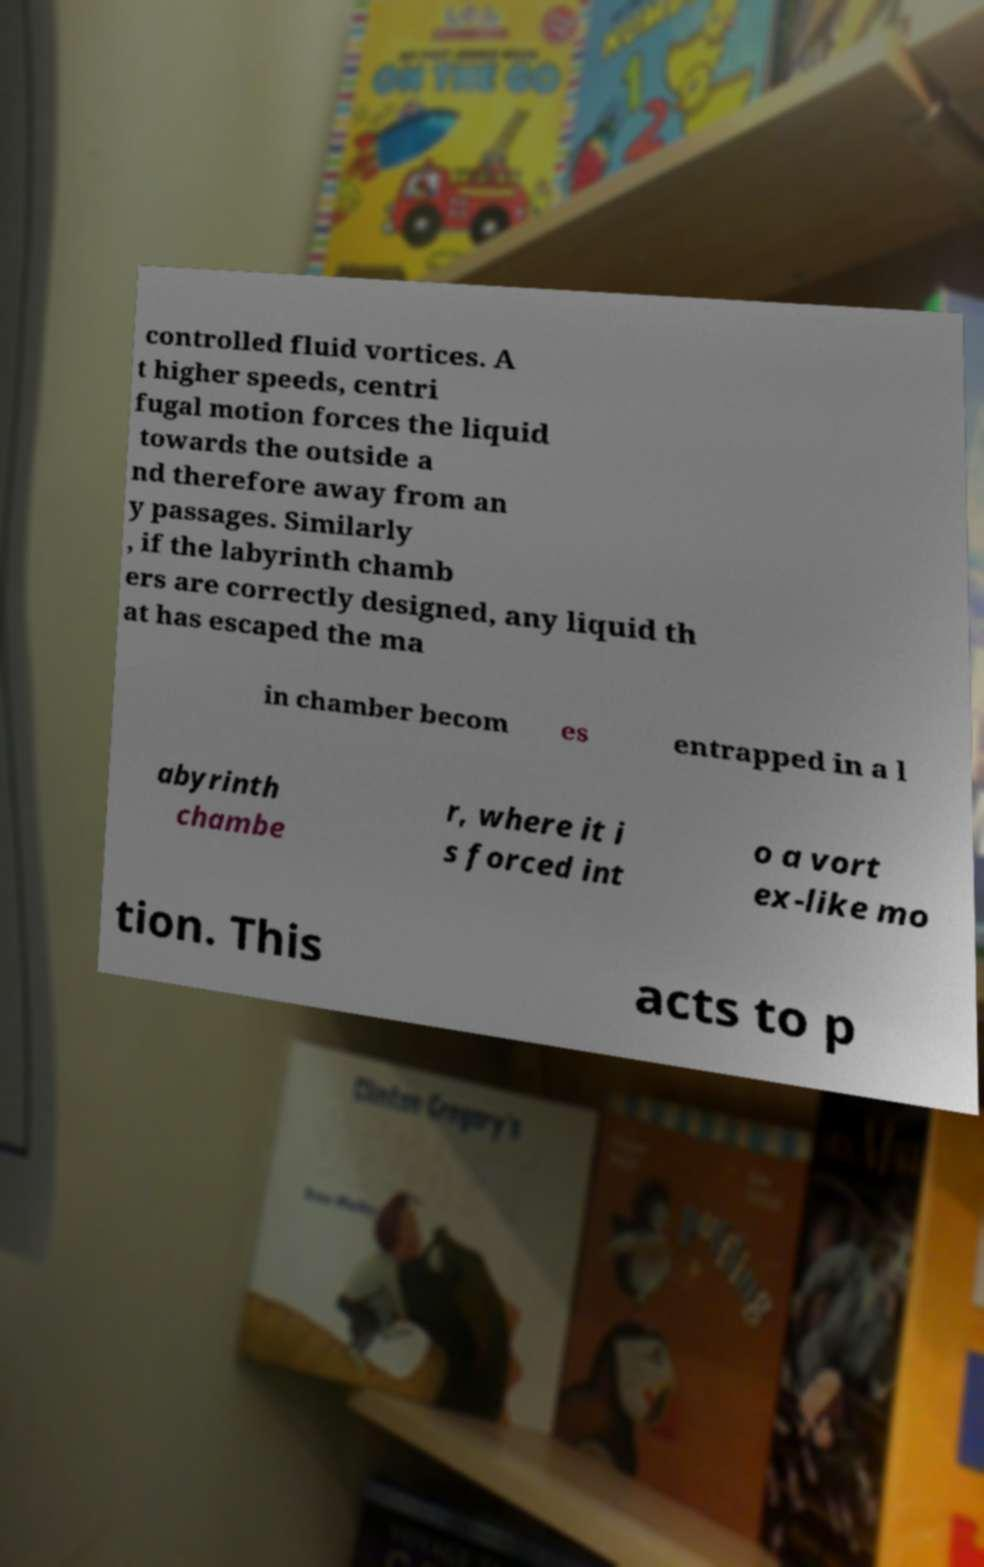Can you accurately transcribe the text from the provided image for me? controlled fluid vortices. A t higher speeds, centri fugal motion forces the liquid towards the outside a nd therefore away from an y passages. Similarly , if the labyrinth chamb ers are correctly designed, any liquid th at has escaped the ma in chamber becom es entrapped in a l abyrinth chambe r, where it i s forced int o a vort ex-like mo tion. This acts to p 